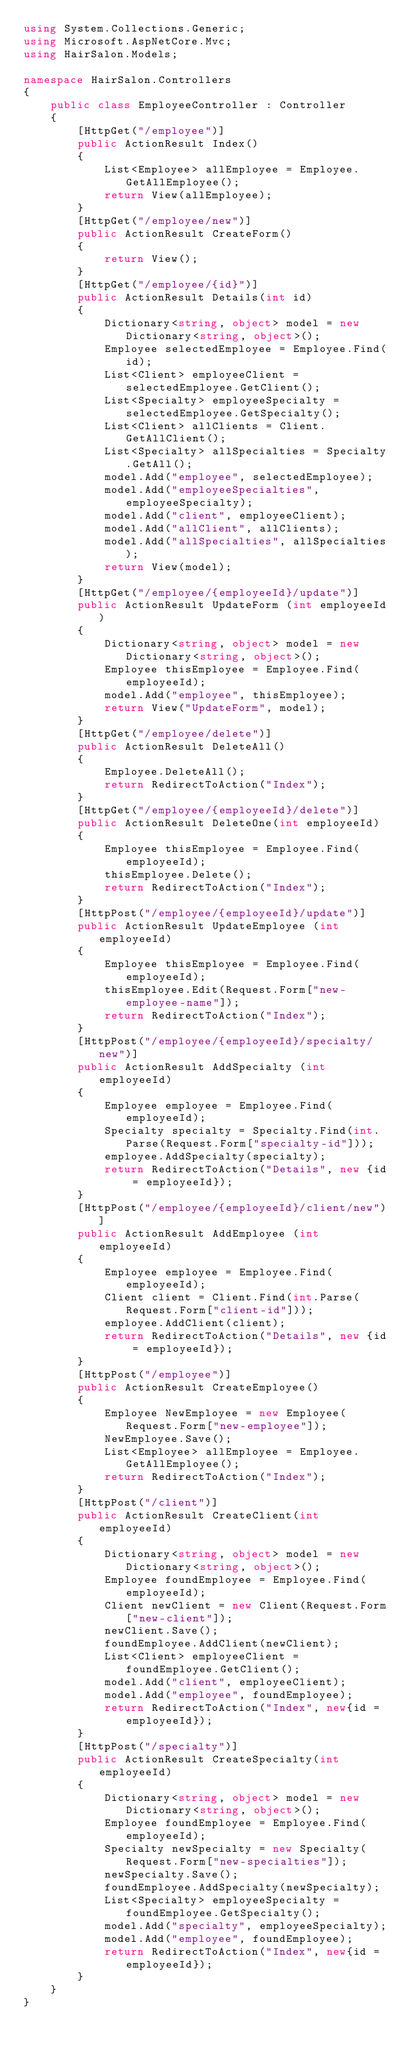Convert code to text. <code><loc_0><loc_0><loc_500><loc_500><_C#_>using System.Collections.Generic;
using Microsoft.AspNetCore.Mvc;
using HairSalon.Models;

namespace HairSalon.Controllers
{
    public class EmployeeController : Controller
    {
        [HttpGet("/employee")]
        public ActionResult Index()
        {
            List<Employee> allEmployee = Employee.GetAllEmployee();
            return View(allEmployee);
        }
        [HttpGet("/employee/new")]
        public ActionResult CreateForm()
        {
            return View();
        }
        [HttpGet("/employee/{id}")]
        public ActionResult Details(int id)
        {
            Dictionary<string, object> model = new Dictionary<string, object>();
            Employee selectedEmployee = Employee.Find(id);
            List<Client> employeeClient = selectedEmployee.GetClient();
            List<Specialty> employeeSpecialty = selectedEmployee.GetSpecialty();
            List<Client> allClients = Client.GetAllClient();
            List<Specialty> allSpecialties = Specialty.GetAll();
            model.Add("employee", selectedEmployee);
            model.Add("employeeSpecialties", employeeSpecialty);
            model.Add("client", employeeClient);
            model.Add("allClient", allClients);
            model.Add("allSpecialties", allSpecialties);
            return View(model);
        }
        [HttpGet("/employee/{employeeId}/update")]
        public ActionResult UpdateForm (int employeeId)
        {
            Dictionary<string, object> model = new Dictionary<string, object>();
            Employee thisEmployee = Employee.Find(employeeId);
            model.Add("employee", thisEmployee);
            return View("UpdateForm", model);
        }
        [HttpGet("/employee/delete")]
        public ActionResult DeleteAll()
        {
            Employee.DeleteAll();
            return RedirectToAction("Index");
        }
        [HttpGet("/employee/{employeeId}/delete")]
        public ActionResult DeleteOne(int employeeId)
        {
            Employee thisEmployee = Employee.Find(employeeId);
            thisEmployee.Delete();
            return RedirectToAction("Index");
        }
        [HttpPost("/employee/{employeeId}/update")]
        public ActionResult UpdateEmployee (int employeeId)
        {
            Employee thisEmployee = Employee.Find(employeeId);
            thisEmployee.Edit(Request.Form["new-employee-name"]);
            return RedirectToAction("Index");
        }
        [HttpPost("/employee/{employeeId}/specialty/new")]
        public ActionResult AddSpecialty (int employeeId)
        {
            Employee employee = Employee.Find(employeeId);
            Specialty specialty = Specialty.Find(int.Parse(Request.Form["specialty-id"]));
            employee.AddSpecialty(specialty);
            return RedirectToAction("Details", new {id = employeeId});
        }
        [HttpPost("/employee/{employeeId}/client/new")]
        public ActionResult AddEmployee (int employeeId)
        {
            Employee employee = Employee.Find(employeeId);
            Client client = Client.Find(int.Parse(Request.Form["client-id"]));
            employee.AddClient(client);
            return RedirectToAction("Details", new {id = employeeId});
        }
        [HttpPost("/employee")]
        public ActionResult CreateEmployee()
        {
            Employee NewEmployee = new Employee(Request.Form["new-employee"]);
            NewEmployee.Save();
            List<Employee> allEmployee = Employee.GetAllEmployee();
            return RedirectToAction("Index");
        }
        [HttpPost("/client")]
        public ActionResult CreateClient(int employeeId)
        {
            Dictionary<string, object> model = new Dictionary<string, object>();
            Employee foundEmployee = Employee.Find(employeeId);
            Client newClient = new Client(Request.Form["new-client"]);
            newClient.Save();
            foundEmployee.AddClient(newClient);
            List<Client> employeeClient = foundEmployee.GetClient();
            model.Add("client", employeeClient);
            model.Add("employee", foundEmployee);
            return RedirectToAction("Index", new{id = employeeId});
        }
        [HttpPost("/specialty")]
        public ActionResult CreateSpecialty(int employeeId)
        {
            Dictionary<string, object> model = new Dictionary<string, object>();
            Employee foundEmployee = Employee.Find(employeeId);
            Specialty newSpecialty = new Specialty(Request.Form["new-specialties"]);
            newSpecialty.Save();
            foundEmployee.AddSpecialty(newSpecialty);
            List<Specialty> employeeSpecialty = foundEmployee.GetSpecialty();
            model.Add("specialty", employeeSpecialty);
            model.Add("employee", foundEmployee);
            return RedirectToAction("Index", new{id = employeeId});
        }
    }
}
</code> 